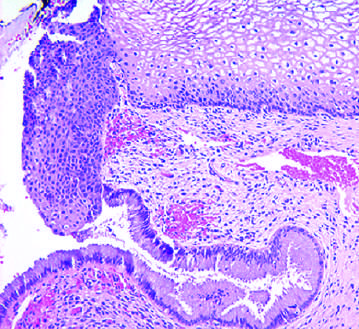did a diagnostic, binucleate reed-sternberg cell show the transition from mature glycogenated squamous epithelium, to immature metaplastic squamous cells, to columnar endocervical glandular epithelium?
Answer the question using a single word or phrase. No 